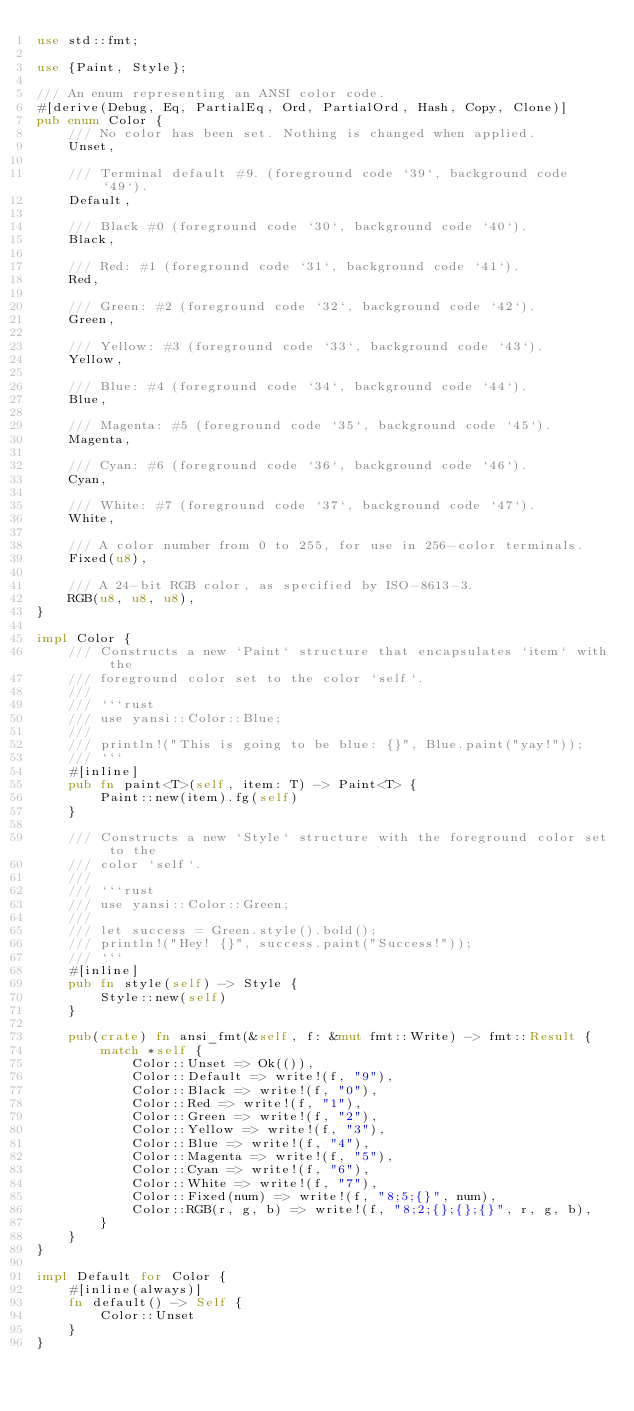<code> <loc_0><loc_0><loc_500><loc_500><_Rust_>use std::fmt;

use {Paint, Style};

/// An enum representing an ANSI color code.
#[derive(Debug, Eq, PartialEq, Ord, PartialOrd, Hash, Copy, Clone)]
pub enum Color {
    /// No color has been set. Nothing is changed when applied.
    Unset,

    /// Terminal default #9. (foreground code `39`, background code `49`).
    Default,

    /// Black #0 (foreground code `30`, background code `40`).
    Black,

    /// Red: #1 (foreground code `31`, background code `41`).
    Red,

    /// Green: #2 (foreground code `32`, background code `42`).
    Green,

    /// Yellow: #3 (foreground code `33`, background code `43`).
    Yellow,

    /// Blue: #4 (foreground code `34`, background code `44`).
    Blue,

    /// Magenta: #5 (foreground code `35`, background code `45`).
    Magenta,

    /// Cyan: #6 (foreground code `36`, background code `46`).
    Cyan,

    /// White: #7 (foreground code `37`, background code `47`).
    White,

    /// A color number from 0 to 255, for use in 256-color terminals.
    Fixed(u8),

    /// A 24-bit RGB color, as specified by ISO-8613-3.
    RGB(u8, u8, u8),
}

impl Color {
    /// Constructs a new `Paint` structure that encapsulates `item` with the
    /// foreground color set to the color `self`.
    ///
    /// ```rust
    /// use yansi::Color::Blue;
    ///
    /// println!("This is going to be blue: {}", Blue.paint("yay!"));
    /// ```
    #[inline]
    pub fn paint<T>(self, item: T) -> Paint<T> {
        Paint::new(item).fg(self)
    }

    /// Constructs a new `Style` structure with the foreground color set to the
    /// color `self`.
    ///
    /// ```rust
    /// use yansi::Color::Green;
    ///
    /// let success = Green.style().bold();
    /// println!("Hey! {}", success.paint("Success!"));
    /// ```
    #[inline]
    pub fn style(self) -> Style {
        Style::new(self)
    }

    pub(crate) fn ansi_fmt(&self, f: &mut fmt::Write) -> fmt::Result {
        match *self {
            Color::Unset => Ok(()),
            Color::Default => write!(f, "9"),
            Color::Black => write!(f, "0"),
            Color::Red => write!(f, "1"),
            Color::Green => write!(f, "2"),
            Color::Yellow => write!(f, "3"),
            Color::Blue => write!(f, "4"),
            Color::Magenta => write!(f, "5"),
            Color::Cyan => write!(f, "6"),
            Color::White => write!(f, "7"),
            Color::Fixed(num) => write!(f, "8;5;{}", num),
            Color::RGB(r, g, b) => write!(f, "8;2;{};{};{}", r, g, b),
        }
    }
}

impl Default for Color {
    #[inline(always)]
    fn default() -> Self {
        Color::Unset
    }
}
</code> 